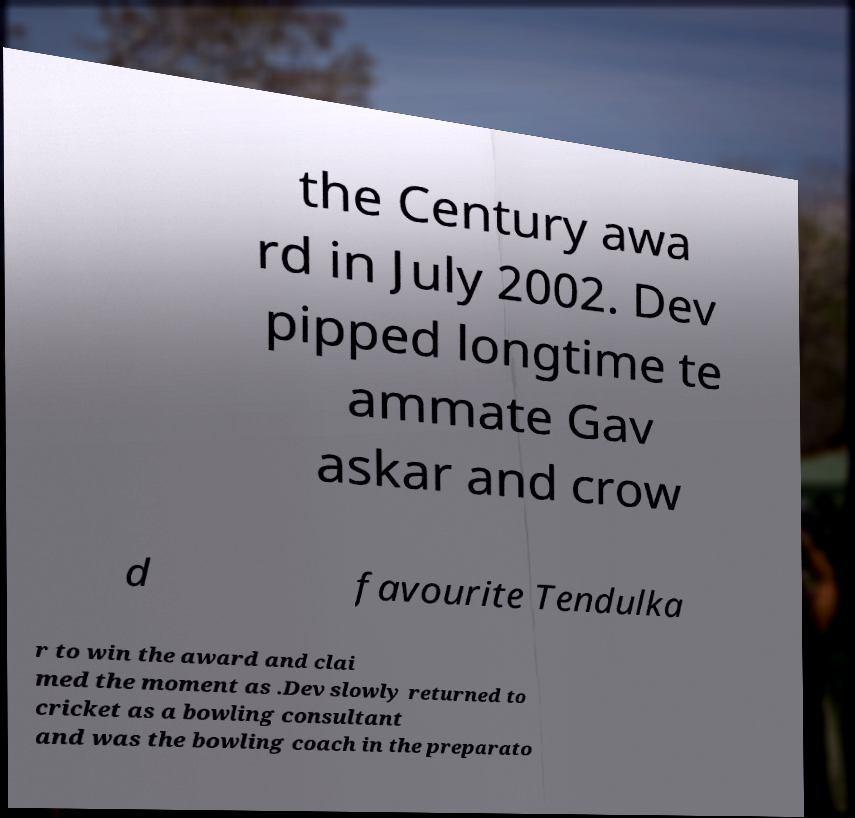Please identify and transcribe the text found in this image. the Century awa rd in July 2002. Dev pipped longtime te ammate Gav askar and crow d favourite Tendulka r to win the award and clai med the moment as .Dev slowly returned to cricket as a bowling consultant and was the bowling coach in the preparato 